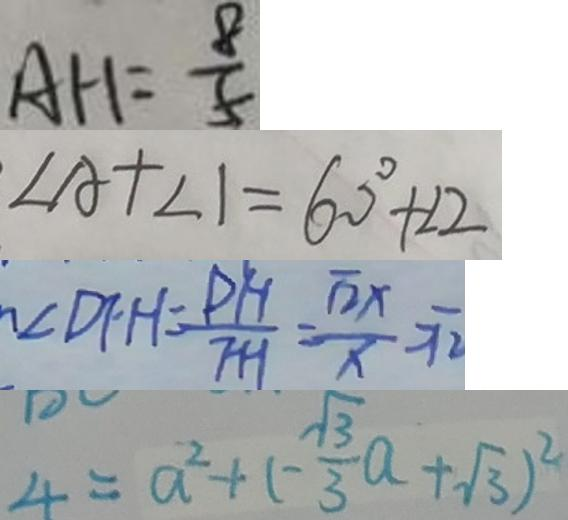<formula> <loc_0><loc_0><loc_500><loc_500>A H = \frac { 8 } { 5 } 
 \angle A + \angle 1 = 6 0 ^ { \circ } + \angle 2 
 \angle D F H = \frac { P H } { F H } = \frac { \sqrt { 2 } x } { x } = \sqrt { 2 } 
 4 = a ^ { 2 } + ( - \frac { \sqrt { 3 } } { 3 } a + \sqrt { 3 } ) ^ { 2 }</formula> 